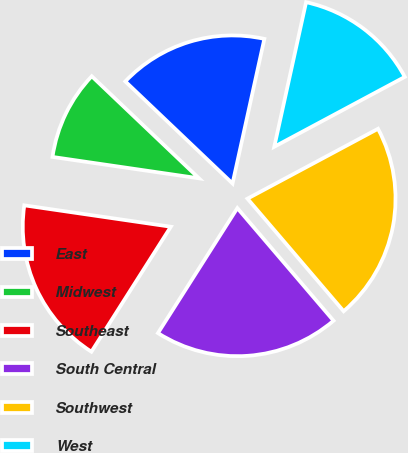Convert chart. <chart><loc_0><loc_0><loc_500><loc_500><pie_chart><fcel>East<fcel>Midwest<fcel>Southeast<fcel>South Central<fcel>Southwest<fcel>West<nl><fcel>16.34%<fcel>9.8%<fcel>18.3%<fcel>20.26%<fcel>21.57%<fcel>13.73%<nl></chart> 